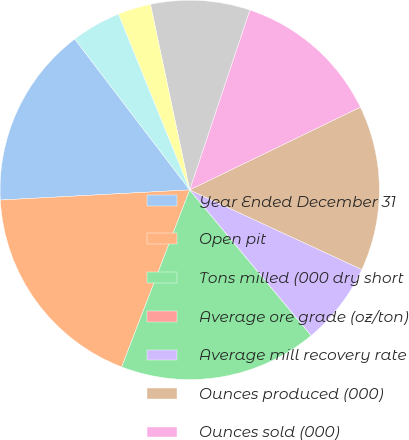Convert chart. <chart><loc_0><loc_0><loc_500><loc_500><pie_chart><fcel>Year Ended December 31<fcel>Open pit<fcel>Tons milled (000 dry short<fcel>Average ore grade (oz/ton)<fcel>Average mill recovery rate<fcel>Ounces produced (000)<fcel>Ounces sold (000)<fcel>Direct mining and production<fcel>By-product credits<fcel>Royalties and production taxes<nl><fcel>15.49%<fcel>18.31%<fcel>16.9%<fcel>0.0%<fcel>7.04%<fcel>14.08%<fcel>12.68%<fcel>8.45%<fcel>2.82%<fcel>4.23%<nl></chart> 